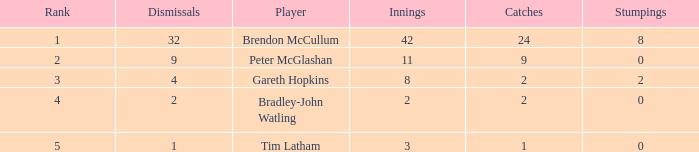How many dismissals did the player Peter McGlashan have? 9.0. 